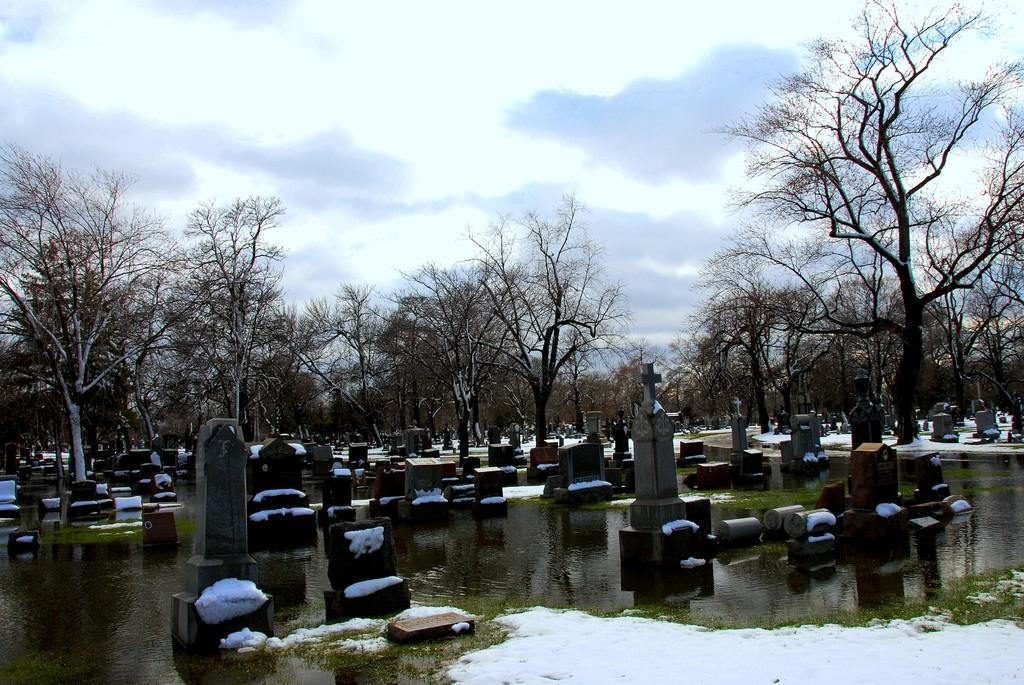What is one of the natural elements visible in the image? There is water in the image. What type of vegetation can be seen in the image? There is grass in the image. What type of location is depicted in the image? There are graveyards in the image. What other natural elements are present in the image? There are trees in the image. What can be seen in the background of the image? The sky is visible in the background of the image, and clouds are present in the sky. What type of treatment is being administered to the edge of the week in the image? There is no treatment or edge of the week present in the image; it features natural elements and a graveyard setting. 